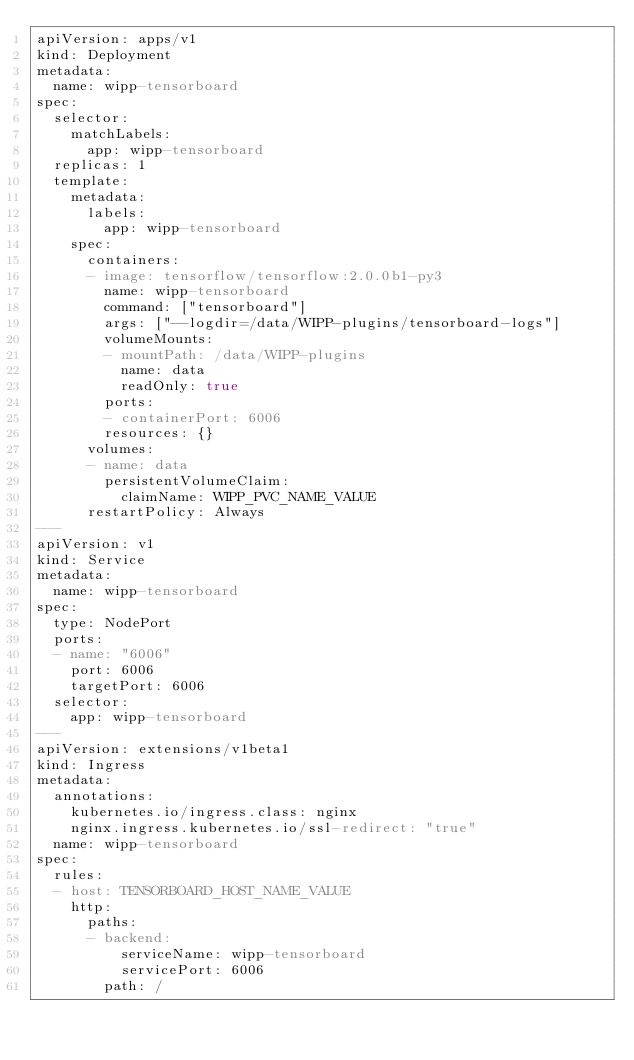Convert code to text. <code><loc_0><loc_0><loc_500><loc_500><_YAML_>apiVersion: apps/v1
kind: Deployment
metadata:
  name: wipp-tensorboard
spec:
  selector:
    matchLabels:
      app: wipp-tensorboard
  replicas: 1
  template:
    metadata:
      labels:
        app: wipp-tensorboard
    spec:
      containers:
      - image: tensorflow/tensorflow:2.0.0b1-py3
        name: wipp-tensorboard
        command: ["tensorboard"]
        args: ["--logdir=/data/WIPP-plugins/tensorboard-logs"]
        volumeMounts:
        - mountPath: /data/WIPP-plugins
          name: data
          readOnly: true
        ports:
        - containerPort: 6006
        resources: {}
      volumes:
      - name: data
        persistentVolumeClaim:
          claimName: WIPP_PVC_NAME_VALUE
      restartPolicy: Always
---
apiVersion: v1
kind: Service
metadata:
  name: wipp-tensorboard
spec:
  type: NodePort
  ports:
  - name: "6006"
    port: 6006
    targetPort: 6006
  selector:
    app: wipp-tensorboard
---
apiVersion: extensions/v1beta1
kind: Ingress
metadata:
  annotations:
    kubernetes.io/ingress.class: nginx
    nginx.ingress.kubernetes.io/ssl-redirect: "true"
  name: wipp-tensorboard
spec:
  rules:
  - host: TENSORBOARD_HOST_NAME_VALUE
    http:
      paths:
      - backend:
          serviceName: wipp-tensorboard
          servicePort: 6006
        path: /
</code> 